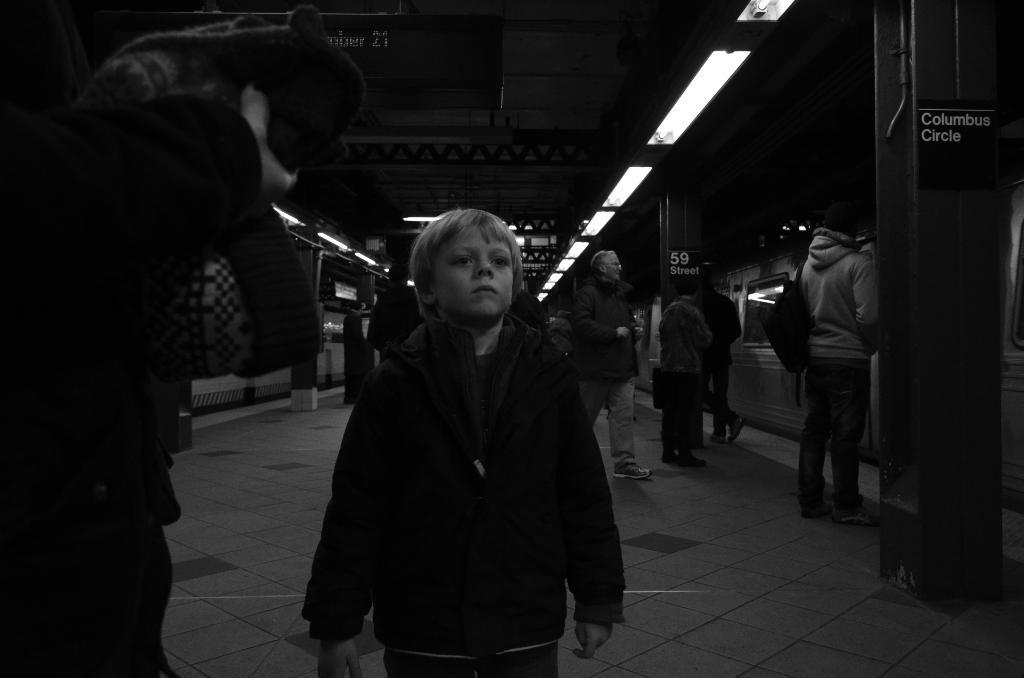What is the color scheme of the image? The image is black and white. What can be seen on the platform in the image? There are people walking on a platform in the image. What is located beside the platform? There is a train beside the platform. What type of lighting is present in the image? There are lights attached to the ceiling in the image. What is the tendency of the game being played on the platform in the image? There is no game being played on the platform in the image. 